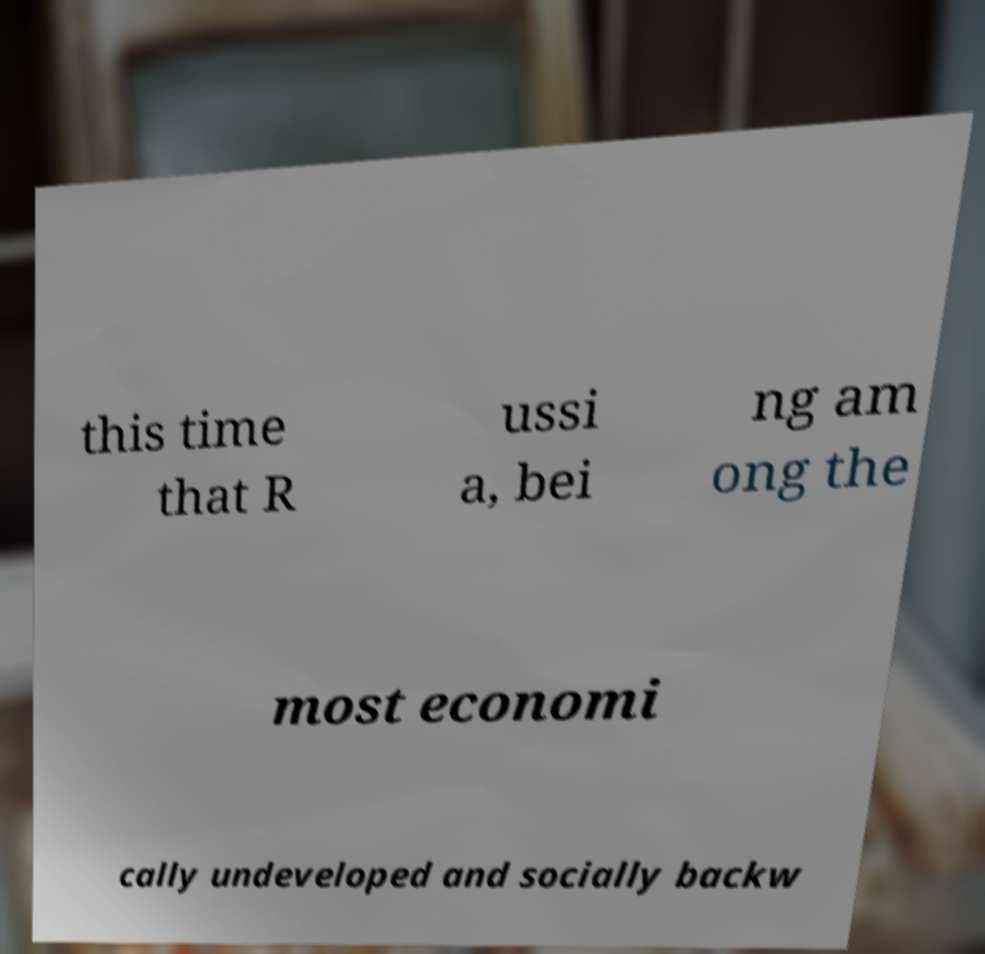I need the written content from this picture converted into text. Can you do that? this time that R ussi a, bei ng am ong the most economi cally undeveloped and socially backw 